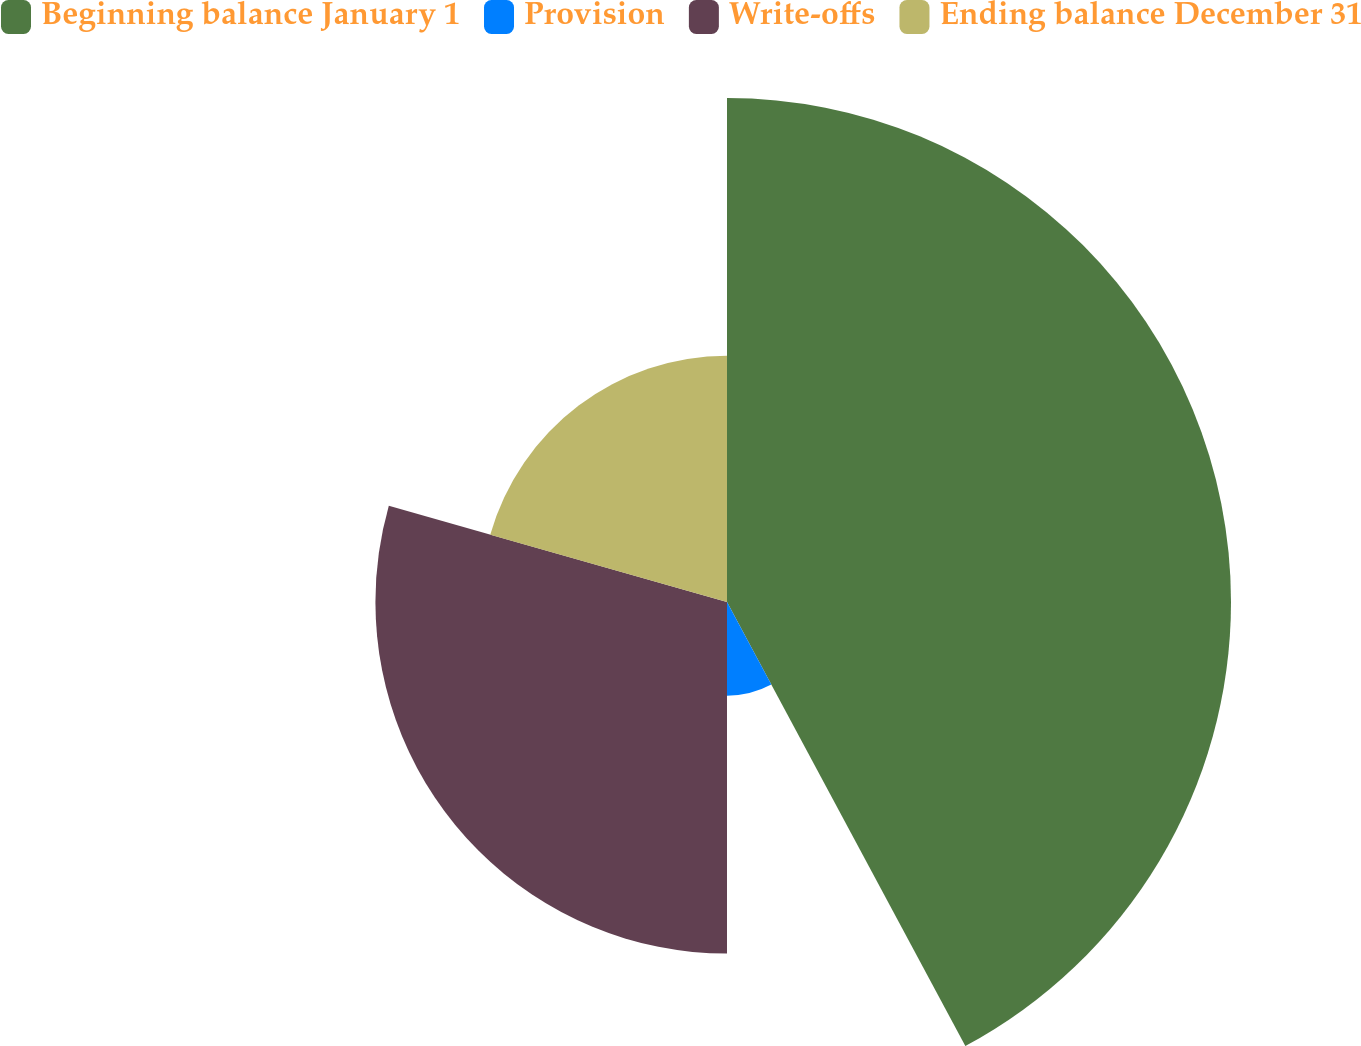<chart> <loc_0><loc_0><loc_500><loc_500><pie_chart><fcel>Beginning balance January 1<fcel>Provision<fcel>Write-offs<fcel>Ending balance December 31<nl><fcel>42.16%<fcel>7.84%<fcel>29.41%<fcel>20.59%<nl></chart> 